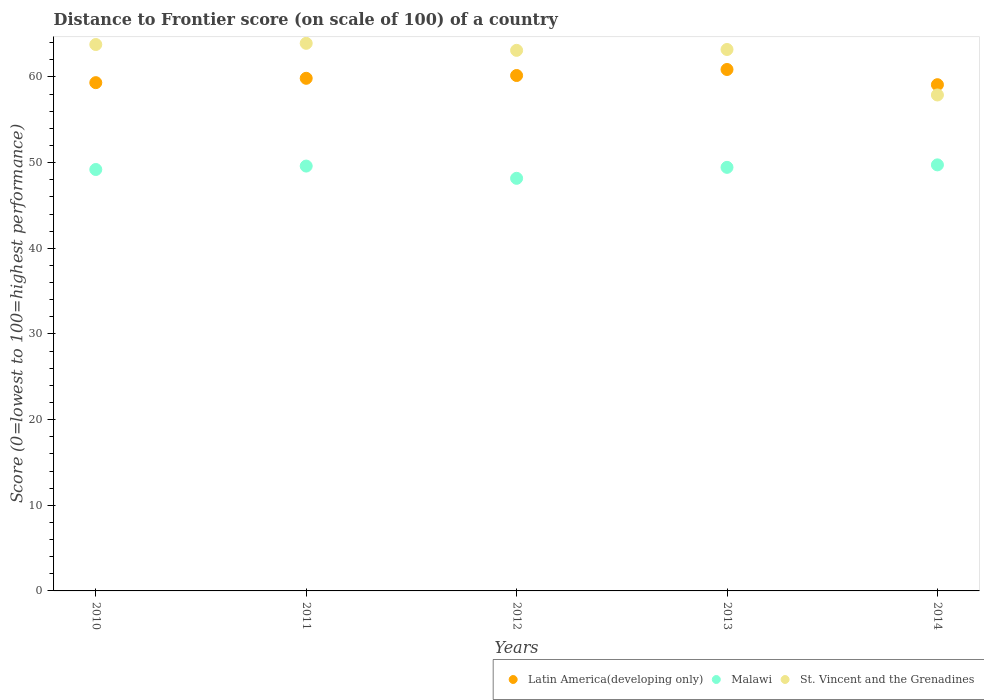How many different coloured dotlines are there?
Your response must be concise. 3. Is the number of dotlines equal to the number of legend labels?
Offer a terse response. Yes. What is the distance to frontier score of in Malawi in 2011?
Keep it short and to the point. 49.6. Across all years, what is the maximum distance to frontier score of in St. Vincent and the Grenadines?
Ensure brevity in your answer.  63.93. Across all years, what is the minimum distance to frontier score of in Latin America(developing only)?
Offer a terse response. 59.1. In which year was the distance to frontier score of in Latin America(developing only) minimum?
Offer a terse response. 2014. What is the total distance to frontier score of in St. Vincent and the Grenadines in the graph?
Your answer should be very brief. 311.94. What is the difference between the distance to frontier score of in Latin America(developing only) in 2013 and that in 2014?
Your response must be concise. 1.77. What is the difference between the distance to frontier score of in St. Vincent and the Grenadines in 2013 and the distance to frontier score of in Latin America(developing only) in 2014?
Your answer should be very brief. 4.11. What is the average distance to frontier score of in Latin America(developing only) per year?
Your answer should be compact. 59.87. In the year 2014, what is the difference between the distance to frontier score of in Latin America(developing only) and distance to frontier score of in Malawi?
Offer a very short reply. 9.36. In how many years, is the distance to frontier score of in Latin America(developing only) greater than 36?
Give a very brief answer. 5. What is the ratio of the distance to frontier score of in St. Vincent and the Grenadines in 2010 to that in 2011?
Provide a succinct answer. 1. Is the distance to frontier score of in St. Vincent and the Grenadines in 2010 less than that in 2011?
Your answer should be very brief. Yes. What is the difference between the highest and the second highest distance to frontier score of in St. Vincent and the Grenadines?
Offer a very short reply. 0.14. What is the difference between the highest and the lowest distance to frontier score of in Latin America(developing only)?
Your response must be concise. 1.77. In how many years, is the distance to frontier score of in Malawi greater than the average distance to frontier score of in Malawi taken over all years?
Your answer should be very brief. 3. Is it the case that in every year, the sum of the distance to frontier score of in Latin America(developing only) and distance to frontier score of in Malawi  is greater than the distance to frontier score of in St. Vincent and the Grenadines?
Your answer should be very brief. Yes. Does the distance to frontier score of in Malawi monotonically increase over the years?
Offer a terse response. No. How many years are there in the graph?
Provide a short and direct response. 5. What is the difference between two consecutive major ticks on the Y-axis?
Your response must be concise. 10. Are the values on the major ticks of Y-axis written in scientific E-notation?
Your answer should be very brief. No. Does the graph contain any zero values?
Provide a succinct answer. No. Does the graph contain grids?
Keep it short and to the point. No. How many legend labels are there?
Keep it short and to the point. 3. How are the legend labels stacked?
Your response must be concise. Horizontal. What is the title of the graph?
Your answer should be very brief. Distance to Frontier score (on scale of 100) of a country. What is the label or title of the Y-axis?
Offer a very short reply. Score (0=lowest to 100=highest performance). What is the Score (0=lowest to 100=highest performance) in Latin America(developing only) in 2010?
Give a very brief answer. 59.34. What is the Score (0=lowest to 100=highest performance) of Malawi in 2010?
Your answer should be very brief. 49.2. What is the Score (0=lowest to 100=highest performance) of St. Vincent and the Grenadines in 2010?
Your answer should be very brief. 63.79. What is the Score (0=lowest to 100=highest performance) of Latin America(developing only) in 2011?
Keep it short and to the point. 59.85. What is the Score (0=lowest to 100=highest performance) of Malawi in 2011?
Ensure brevity in your answer.  49.6. What is the Score (0=lowest to 100=highest performance) in St. Vincent and the Grenadines in 2011?
Keep it short and to the point. 63.93. What is the Score (0=lowest to 100=highest performance) of Latin America(developing only) in 2012?
Your answer should be very brief. 60.17. What is the Score (0=lowest to 100=highest performance) in Malawi in 2012?
Your response must be concise. 48.17. What is the Score (0=lowest to 100=highest performance) in St. Vincent and the Grenadines in 2012?
Your answer should be compact. 63.11. What is the Score (0=lowest to 100=highest performance) in Latin America(developing only) in 2013?
Give a very brief answer. 60.88. What is the Score (0=lowest to 100=highest performance) in Malawi in 2013?
Your response must be concise. 49.45. What is the Score (0=lowest to 100=highest performance) in St. Vincent and the Grenadines in 2013?
Make the answer very short. 63.21. What is the Score (0=lowest to 100=highest performance) in Latin America(developing only) in 2014?
Offer a terse response. 59.1. What is the Score (0=lowest to 100=highest performance) in Malawi in 2014?
Your answer should be compact. 49.74. What is the Score (0=lowest to 100=highest performance) of St. Vincent and the Grenadines in 2014?
Your answer should be compact. 57.9. Across all years, what is the maximum Score (0=lowest to 100=highest performance) of Latin America(developing only)?
Your answer should be compact. 60.88. Across all years, what is the maximum Score (0=lowest to 100=highest performance) in Malawi?
Make the answer very short. 49.74. Across all years, what is the maximum Score (0=lowest to 100=highest performance) of St. Vincent and the Grenadines?
Give a very brief answer. 63.93. Across all years, what is the minimum Score (0=lowest to 100=highest performance) in Latin America(developing only)?
Provide a short and direct response. 59.1. Across all years, what is the minimum Score (0=lowest to 100=highest performance) in Malawi?
Give a very brief answer. 48.17. Across all years, what is the minimum Score (0=lowest to 100=highest performance) of St. Vincent and the Grenadines?
Your response must be concise. 57.9. What is the total Score (0=lowest to 100=highest performance) in Latin America(developing only) in the graph?
Offer a terse response. 299.33. What is the total Score (0=lowest to 100=highest performance) in Malawi in the graph?
Provide a short and direct response. 246.16. What is the total Score (0=lowest to 100=highest performance) in St. Vincent and the Grenadines in the graph?
Ensure brevity in your answer.  311.94. What is the difference between the Score (0=lowest to 100=highest performance) in Latin America(developing only) in 2010 and that in 2011?
Your answer should be very brief. -0.51. What is the difference between the Score (0=lowest to 100=highest performance) of St. Vincent and the Grenadines in 2010 and that in 2011?
Provide a succinct answer. -0.14. What is the difference between the Score (0=lowest to 100=highest performance) of Latin America(developing only) in 2010 and that in 2012?
Make the answer very short. -0.83. What is the difference between the Score (0=lowest to 100=highest performance) in Malawi in 2010 and that in 2012?
Your answer should be compact. 1.03. What is the difference between the Score (0=lowest to 100=highest performance) in St. Vincent and the Grenadines in 2010 and that in 2012?
Give a very brief answer. 0.68. What is the difference between the Score (0=lowest to 100=highest performance) of Latin America(developing only) in 2010 and that in 2013?
Make the answer very short. -1.54. What is the difference between the Score (0=lowest to 100=highest performance) in St. Vincent and the Grenadines in 2010 and that in 2013?
Your answer should be very brief. 0.58. What is the difference between the Score (0=lowest to 100=highest performance) of Latin America(developing only) in 2010 and that in 2014?
Offer a very short reply. 0.24. What is the difference between the Score (0=lowest to 100=highest performance) of Malawi in 2010 and that in 2014?
Offer a very short reply. -0.54. What is the difference between the Score (0=lowest to 100=highest performance) of St. Vincent and the Grenadines in 2010 and that in 2014?
Give a very brief answer. 5.89. What is the difference between the Score (0=lowest to 100=highest performance) in Latin America(developing only) in 2011 and that in 2012?
Provide a succinct answer. -0.33. What is the difference between the Score (0=lowest to 100=highest performance) of Malawi in 2011 and that in 2012?
Your response must be concise. 1.43. What is the difference between the Score (0=lowest to 100=highest performance) in St. Vincent and the Grenadines in 2011 and that in 2012?
Your response must be concise. 0.82. What is the difference between the Score (0=lowest to 100=highest performance) of Latin America(developing only) in 2011 and that in 2013?
Your answer should be compact. -1.03. What is the difference between the Score (0=lowest to 100=highest performance) of St. Vincent and the Grenadines in 2011 and that in 2013?
Your answer should be very brief. 0.72. What is the difference between the Score (0=lowest to 100=highest performance) of Latin America(developing only) in 2011 and that in 2014?
Provide a short and direct response. 0.75. What is the difference between the Score (0=lowest to 100=highest performance) of Malawi in 2011 and that in 2014?
Your response must be concise. -0.14. What is the difference between the Score (0=lowest to 100=highest performance) in St. Vincent and the Grenadines in 2011 and that in 2014?
Provide a short and direct response. 6.03. What is the difference between the Score (0=lowest to 100=highest performance) in Latin America(developing only) in 2012 and that in 2013?
Offer a terse response. -0.7. What is the difference between the Score (0=lowest to 100=highest performance) of Malawi in 2012 and that in 2013?
Your response must be concise. -1.28. What is the difference between the Score (0=lowest to 100=highest performance) of Latin America(developing only) in 2012 and that in 2014?
Make the answer very short. 1.07. What is the difference between the Score (0=lowest to 100=highest performance) in Malawi in 2012 and that in 2014?
Provide a short and direct response. -1.57. What is the difference between the Score (0=lowest to 100=highest performance) in St. Vincent and the Grenadines in 2012 and that in 2014?
Offer a terse response. 5.21. What is the difference between the Score (0=lowest to 100=highest performance) in Latin America(developing only) in 2013 and that in 2014?
Offer a very short reply. 1.77. What is the difference between the Score (0=lowest to 100=highest performance) in Malawi in 2013 and that in 2014?
Your answer should be compact. -0.29. What is the difference between the Score (0=lowest to 100=highest performance) in St. Vincent and the Grenadines in 2013 and that in 2014?
Offer a terse response. 5.31. What is the difference between the Score (0=lowest to 100=highest performance) of Latin America(developing only) in 2010 and the Score (0=lowest to 100=highest performance) of Malawi in 2011?
Your response must be concise. 9.74. What is the difference between the Score (0=lowest to 100=highest performance) of Latin America(developing only) in 2010 and the Score (0=lowest to 100=highest performance) of St. Vincent and the Grenadines in 2011?
Ensure brevity in your answer.  -4.59. What is the difference between the Score (0=lowest to 100=highest performance) in Malawi in 2010 and the Score (0=lowest to 100=highest performance) in St. Vincent and the Grenadines in 2011?
Offer a very short reply. -14.73. What is the difference between the Score (0=lowest to 100=highest performance) in Latin America(developing only) in 2010 and the Score (0=lowest to 100=highest performance) in Malawi in 2012?
Provide a succinct answer. 11.17. What is the difference between the Score (0=lowest to 100=highest performance) of Latin America(developing only) in 2010 and the Score (0=lowest to 100=highest performance) of St. Vincent and the Grenadines in 2012?
Make the answer very short. -3.77. What is the difference between the Score (0=lowest to 100=highest performance) in Malawi in 2010 and the Score (0=lowest to 100=highest performance) in St. Vincent and the Grenadines in 2012?
Provide a short and direct response. -13.91. What is the difference between the Score (0=lowest to 100=highest performance) in Latin America(developing only) in 2010 and the Score (0=lowest to 100=highest performance) in Malawi in 2013?
Provide a succinct answer. 9.89. What is the difference between the Score (0=lowest to 100=highest performance) in Latin America(developing only) in 2010 and the Score (0=lowest to 100=highest performance) in St. Vincent and the Grenadines in 2013?
Provide a short and direct response. -3.87. What is the difference between the Score (0=lowest to 100=highest performance) of Malawi in 2010 and the Score (0=lowest to 100=highest performance) of St. Vincent and the Grenadines in 2013?
Ensure brevity in your answer.  -14.01. What is the difference between the Score (0=lowest to 100=highest performance) in Latin America(developing only) in 2010 and the Score (0=lowest to 100=highest performance) in Malawi in 2014?
Provide a succinct answer. 9.6. What is the difference between the Score (0=lowest to 100=highest performance) in Latin America(developing only) in 2010 and the Score (0=lowest to 100=highest performance) in St. Vincent and the Grenadines in 2014?
Give a very brief answer. 1.44. What is the difference between the Score (0=lowest to 100=highest performance) of Malawi in 2010 and the Score (0=lowest to 100=highest performance) of St. Vincent and the Grenadines in 2014?
Provide a short and direct response. -8.7. What is the difference between the Score (0=lowest to 100=highest performance) in Latin America(developing only) in 2011 and the Score (0=lowest to 100=highest performance) in Malawi in 2012?
Provide a short and direct response. 11.68. What is the difference between the Score (0=lowest to 100=highest performance) in Latin America(developing only) in 2011 and the Score (0=lowest to 100=highest performance) in St. Vincent and the Grenadines in 2012?
Your answer should be compact. -3.26. What is the difference between the Score (0=lowest to 100=highest performance) of Malawi in 2011 and the Score (0=lowest to 100=highest performance) of St. Vincent and the Grenadines in 2012?
Make the answer very short. -13.51. What is the difference between the Score (0=lowest to 100=highest performance) in Latin America(developing only) in 2011 and the Score (0=lowest to 100=highest performance) in Malawi in 2013?
Offer a very short reply. 10.4. What is the difference between the Score (0=lowest to 100=highest performance) in Latin America(developing only) in 2011 and the Score (0=lowest to 100=highest performance) in St. Vincent and the Grenadines in 2013?
Give a very brief answer. -3.36. What is the difference between the Score (0=lowest to 100=highest performance) in Malawi in 2011 and the Score (0=lowest to 100=highest performance) in St. Vincent and the Grenadines in 2013?
Your answer should be very brief. -13.61. What is the difference between the Score (0=lowest to 100=highest performance) of Latin America(developing only) in 2011 and the Score (0=lowest to 100=highest performance) of Malawi in 2014?
Make the answer very short. 10.11. What is the difference between the Score (0=lowest to 100=highest performance) of Latin America(developing only) in 2011 and the Score (0=lowest to 100=highest performance) of St. Vincent and the Grenadines in 2014?
Offer a very short reply. 1.95. What is the difference between the Score (0=lowest to 100=highest performance) in Malawi in 2011 and the Score (0=lowest to 100=highest performance) in St. Vincent and the Grenadines in 2014?
Make the answer very short. -8.3. What is the difference between the Score (0=lowest to 100=highest performance) of Latin America(developing only) in 2012 and the Score (0=lowest to 100=highest performance) of Malawi in 2013?
Your answer should be compact. 10.72. What is the difference between the Score (0=lowest to 100=highest performance) in Latin America(developing only) in 2012 and the Score (0=lowest to 100=highest performance) in St. Vincent and the Grenadines in 2013?
Give a very brief answer. -3.04. What is the difference between the Score (0=lowest to 100=highest performance) of Malawi in 2012 and the Score (0=lowest to 100=highest performance) of St. Vincent and the Grenadines in 2013?
Offer a very short reply. -15.04. What is the difference between the Score (0=lowest to 100=highest performance) of Latin America(developing only) in 2012 and the Score (0=lowest to 100=highest performance) of Malawi in 2014?
Provide a succinct answer. 10.43. What is the difference between the Score (0=lowest to 100=highest performance) of Latin America(developing only) in 2012 and the Score (0=lowest to 100=highest performance) of St. Vincent and the Grenadines in 2014?
Make the answer very short. 2.27. What is the difference between the Score (0=lowest to 100=highest performance) of Malawi in 2012 and the Score (0=lowest to 100=highest performance) of St. Vincent and the Grenadines in 2014?
Make the answer very short. -9.73. What is the difference between the Score (0=lowest to 100=highest performance) in Latin America(developing only) in 2013 and the Score (0=lowest to 100=highest performance) in Malawi in 2014?
Offer a terse response. 11.14. What is the difference between the Score (0=lowest to 100=highest performance) in Latin America(developing only) in 2013 and the Score (0=lowest to 100=highest performance) in St. Vincent and the Grenadines in 2014?
Keep it short and to the point. 2.98. What is the difference between the Score (0=lowest to 100=highest performance) in Malawi in 2013 and the Score (0=lowest to 100=highest performance) in St. Vincent and the Grenadines in 2014?
Offer a terse response. -8.45. What is the average Score (0=lowest to 100=highest performance) in Latin America(developing only) per year?
Offer a very short reply. 59.87. What is the average Score (0=lowest to 100=highest performance) of Malawi per year?
Give a very brief answer. 49.23. What is the average Score (0=lowest to 100=highest performance) of St. Vincent and the Grenadines per year?
Your answer should be very brief. 62.39. In the year 2010, what is the difference between the Score (0=lowest to 100=highest performance) in Latin America(developing only) and Score (0=lowest to 100=highest performance) in Malawi?
Your response must be concise. 10.14. In the year 2010, what is the difference between the Score (0=lowest to 100=highest performance) in Latin America(developing only) and Score (0=lowest to 100=highest performance) in St. Vincent and the Grenadines?
Your response must be concise. -4.45. In the year 2010, what is the difference between the Score (0=lowest to 100=highest performance) of Malawi and Score (0=lowest to 100=highest performance) of St. Vincent and the Grenadines?
Ensure brevity in your answer.  -14.59. In the year 2011, what is the difference between the Score (0=lowest to 100=highest performance) in Latin America(developing only) and Score (0=lowest to 100=highest performance) in Malawi?
Make the answer very short. 10.25. In the year 2011, what is the difference between the Score (0=lowest to 100=highest performance) in Latin America(developing only) and Score (0=lowest to 100=highest performance) in St. Vincent and the Grenadines?
Your answer should be compact. -4.08. In the year 2011, what is the difference between the Score (0=lowest to 100=highest performance) of Malawi and Score (0=lowest to 100=highest performance) of St. Vincent and the Grenadines?
Keep it short and to the point. -14.33. In the year 2012, what is the difference between the Score (0=lowest to 100=highest performance) of Latin America(developing only) and Score (0=lowest to 100=highest performance) of Malawi?
Your answer should be very brief. 12. In the year 2012, what is the difference between the Score (0=lowest to 100=highest performance) in Latin America(developing only) and Score (0=lowest to 100=highest performance) in St. Vincent and the Grenadines?
Your answer should be very brief. -2.94. In the year 2012, what is the difference between the Score (0=lowest to 100=highest performance) in Malawi and Score (0=lowest to 100=highest performance) in St. Vincent and the Grenadines?
Keep it short and to the point. -14.94. In the year 2013, what is the difference between the Score (0=lowest to 100=highest performance) of Latin America(developing only) and Score (0=lowest to 100=highest performance) of Malawi?
Offer a terse response. 11.43. In the year 2013, what is the difference between the Score (0=lowest to 100=highest performance) in Latin America(developing only) and Score (0=lowest to 100=highest performance) in St. Vincent and the Grenadines?
Offer a very short reply. -2.33. In the year 2013, what is the difference between the Score (0=lowest to 100=highest performance) in Malawi and Score (0=lowest to 100=highest performance) in St. Vincent and the Grenadines?
Keep it short and to the point. -13.76. In the year 2014, what is the difference between the Score (0=lowest to 100=highest performance) of Latin America(developing only) and Score (0=lowest to 100=highest performance) of Malawi?
Keep it short and to the point. 9.36. In the year 2014, what is the difference between the Score (0=lowest to 100=highest performance) of Latin America(developing only) and Score (0=lowest to 100=highest performance) of St. Vincent and the Grenadines?
Provide a short and direct response. 1.2. In the year 2014, what is the difference between the Score (0=lowest to 100=highest performance) of Malawi and Score (0=lowest to 100=highest performance) of St. Vincent and the Grenadines?
Your answer should be very brief. -8.16. What is the ratio of the Score (0=lowest to 100=highest performance) of St. Vincent and the Grenadines in 2010 to that in 2011?
Offer a terse response. 1. What is the ratio of the Score (0=lowest to 100=highest performance) of Latin America(developing only) in 2010 to that in 2012?
Provide a short and direct response. 0.99. What is the ratio of the Score (0=lowest to 100=highest performance) of Malawi in 2010 to that in 2012?
Ensure brevity in your answer.  1.02. What is the ratio of the Score (0=lowest to 100=highest performance) of St. Vincent and the Grenadines in 2010 to that in 2012?
Offer a very short reply. 1.01. What is the ratio of the Score (0=lowest to 100=highest performance) in Latin America(developing only) in 2010 to that in 2013?
Give a very brief answer. 0.97. What is the ratio of the Score (0=lowest to 100=highest performance) of Malawi in 2010 to that in 2013?
Ensure brevity in your answer.  0.99. What is the ratio of the Score (0=lowest to 100=highest performance) of St. Vincent and the Grenadines in 2010 to that in 2013?
Provide a succinct answer. 1.01. What is the ratio of the Score (0=lowest to 100=highest performance) in Latin America(developing only) in 2010 to that in 2014?
Your response must be concise. 1. What is the ratio of the Score (0=lowest to 100=highest performance) of St. Vincent and the Grenadines in 2010 to that in 2014?
Keep it short and to the point. 1.1. What is the ratio of the Score (0=lowest to 100=highest performance) in Malawi in 2011 to that in 2012?
Your answer should be very brief. 1.03. What is the ratio of the Score (0=lowest to 100=highest performance) in St. Vincent and the Grenadines in 2011 to that in 2012?
Your answer should be very brief. 1.01. What is the ratio of the Score (0=lowest to 100=highest performance) of Latin America(developing only) in 2011 to that in 2013?
Make the answer very short. 0.98. What is the ratio of the Score (0=lowest to 100=highest performance) of Malawi in 2011 to that in 2013?
Keep it short and to the point. 1. What is the ratio of the Score (0=lowest to 100=highest performance) of St. Vincent and the Grenadines in 2011 to that in 2013?
Provide a succinct answer. 1.01. What is the ratio of the Score (0=lowest to 100=highest performance) of Latin America(developing only) in 2011 to that in 2014?
Your answer should be very brief. 1.01. What is the ratio of the Score (0=lowest to 100=highest performance) of St. Vincent and the Grenadines in 2011 to that in 2014?
Your answer should be compact. 1.1. What is the ratio of the Score (0=lowest to 100=highest performance) of Malawi in 2012 to that in 2013?
Your answer should be compact. 0.97. What is the ratio of the Score (0=lowest to 100=highest performance) of St. Vincent and the Grenadines in 2012 to that in 2013?
Ensure brevity in your answer.  1. What is the ratio of the Score (0=lowest to 100=highest performance) of Latin America(developing only) in 2012 to that in 2014?
Give a very brief answer. 1.02. What is the ratio of the Score (0=lowest to 100=highest performance) in Malawi in 2012 to that in 2014?
Your answer should be very brief. 0.97. What is the ratio of the Score (0=lowest to 100=highest performance) in St. Vincent and the Grenadines in 2012 to that in 2014?
Offer a very short reply. 1.09. What is the ratio of the Score (0=lowest to 100=highest performance) in Malawi in 2013 to that in 2014?
Ensure brevity in your answer.  0.99. What is the ratio of the Score (0=lowest to 100=highest performance) of St. Vincent and the Grenadines in 2013 to that in 2014?
Keep it short and to the point. 1.09. What is the difference between the highest and the second highest Score (0=lowest to 100=highest performance) of Latin America(developing only)?
Offer a terse response. 0.7. What is the difference between the highest and the second highest Score (0=lowest to 100=highest performance) of Malawi?
Your response must be concise. 0.14. What is the difference between the highest and the second highest Score (0=lowest to 100=highest performance) in St. Vincent and the Grenadines?
Give a very brief answer. 0.14. What is the difference between the highest and the lowest Score (0=lowest to 100=highest performance) in Latin America(developing only)?
Offer a very short reply. 1.77. What is the difference between the highest and the lowest Score (0=lowest to 100=highest performance) in Malawi?
Offer a very short reply. 1.57. What is the difference between the highest and the lowest Score (0=lowest to 100=highest performance) of St. Vincent and the Grenadines?
Your answer should be very brief. 6.03. 